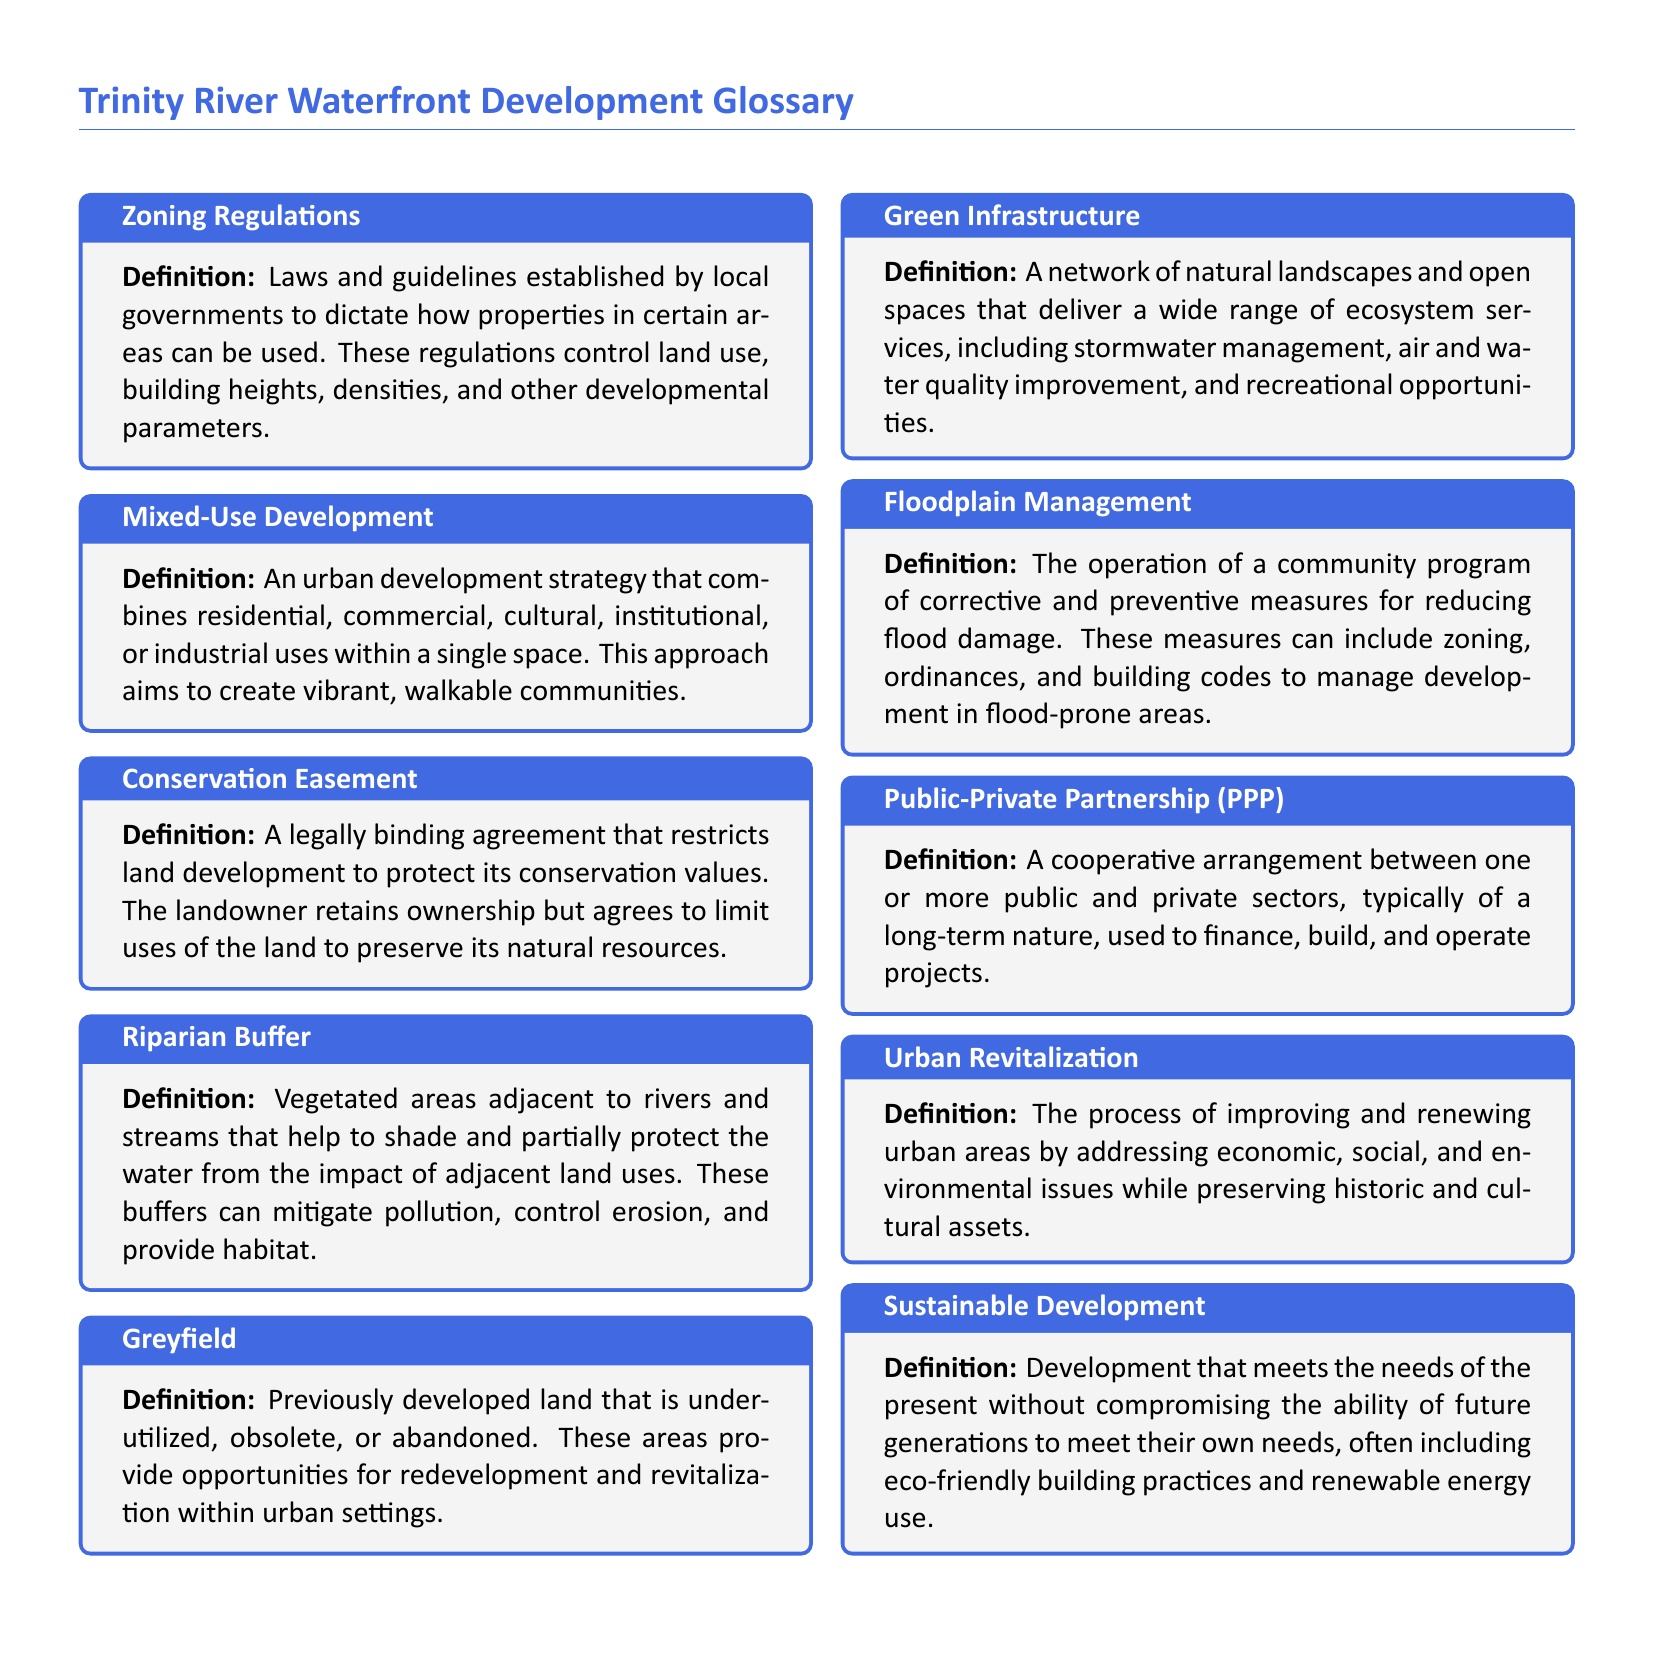What is a Conservation Easement? A Conservation Easement is a legally binding agreement that restricts land development to protect its conservation values, allowing the landowner to retain ownership while limiting uses of the land.
Answer: A legally binding agreement What does Mixed-Use Development aim to create? Mixed-Use Development aims to create vibrant, walkable communities by combining residential, commercial, cultural, institutional, or industrial uses within a single space.
Answer: Vibrant, walkable communities What is Greyfield? Greyfield refers to previously developed land that is underutilized, obsolete, or abandoned, providing opportunities for redevelopment.
Answer: Underutilized, obsolete, or abandoned land What does Urban Revitalization address? Urban Revitalization addresses economic, social, and environmental issues while preserving historic and cultural assets in urban areas.
Answer: Economic, social, and environmental issues What do zoning regulations control? Zoning regulations control land use, building heights, densities, and other developmental parameters in certain areas.
Answer: Land use, building heights, densities What is one function of a Riparian Buffer? One function of a Riparian Buffer is to mitigate pollution and control erosion in adjacent waterways.
Answer: Mitigate pollution What type of partnership is a Public-Private Partnership (PPP)? A Public-Private Partnership (PPP) is a cooperative arrangement between public and private sectors, typically of a long-term nature, used to finance, build, and operate projects.
Answer: Cooperative arrangement What is the purpose of Floodplain Management? The purpose of Floodplain Management is to reduce flood damage through measures like zoning, ordinances, and building codes.
Answer: Reduce flood damage What is Green Infrastructure? Green Infrastructure refers to a network of natural landscapes and open spaces that deliver ecosystem services, including stormwater management and recreational opportunities.
Answer: Network of natural landscapes What is Sustainable Development? Sustainable Development meets the needs of the present without compromising future generations' ability to meet their needs, often including eco-friendly practices.
Answer: Meets present needs sustainably 